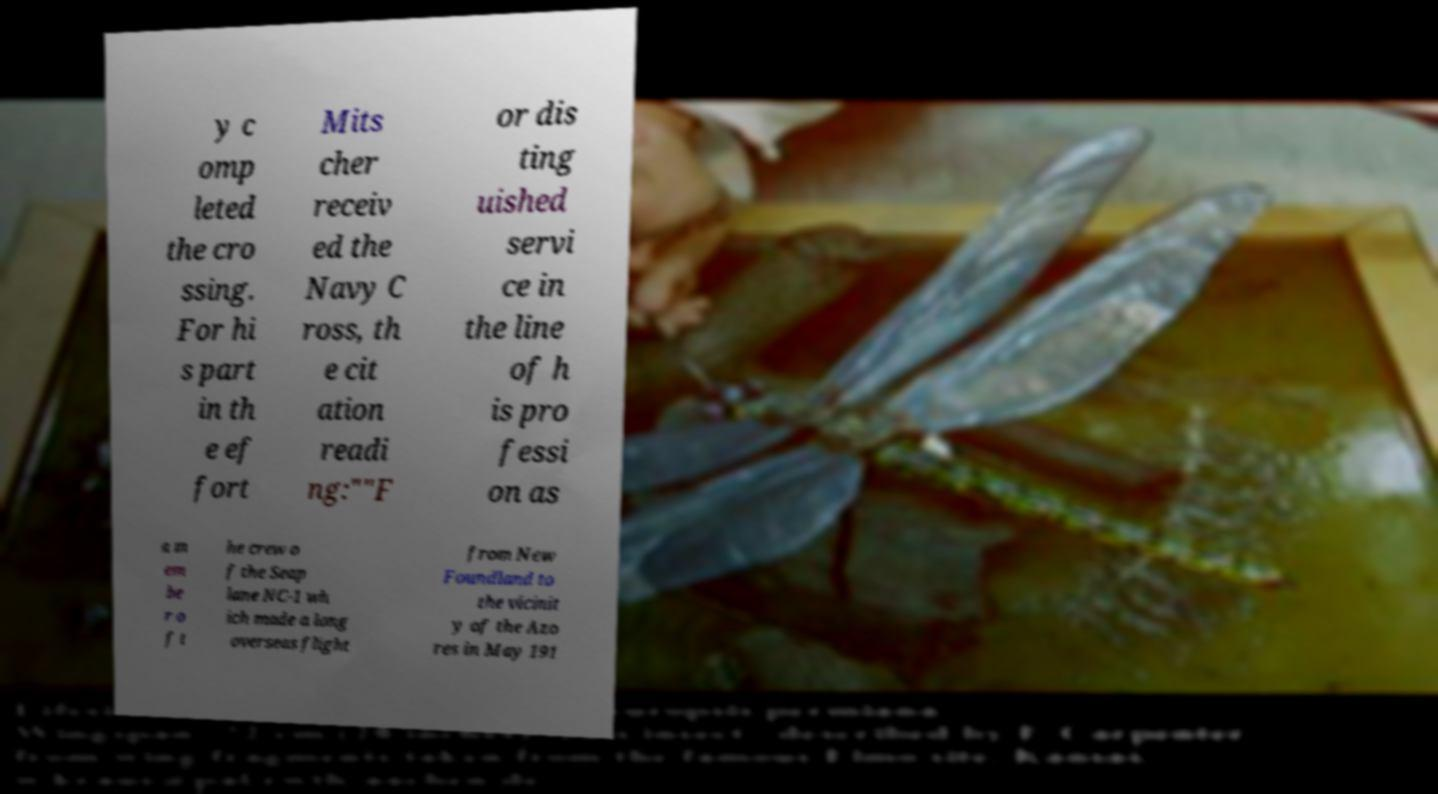Please identify and transcribe the text found in this image. y c omp leted the cro ssing. For hi s part in th e ef fort Mits cher receiv ed the Navy C ross, th e cit ation readi ng:""F or dis ting uished servi ce in the line of h is pro fessi on as a m em be r o f t he crew o f the Seap lane NC-1 wh ich made a long overseas flight from New Foundland to the vicinit y of the Azo res in May 191 